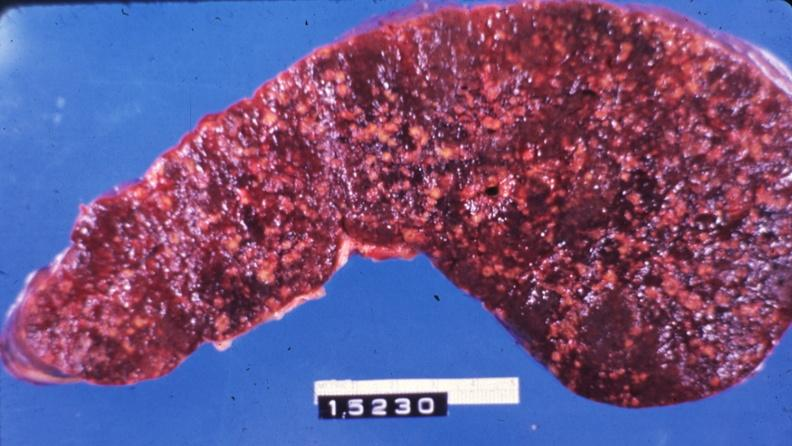what is present?
Answer the question using a single word or phrase. Malignant histiocytosis 